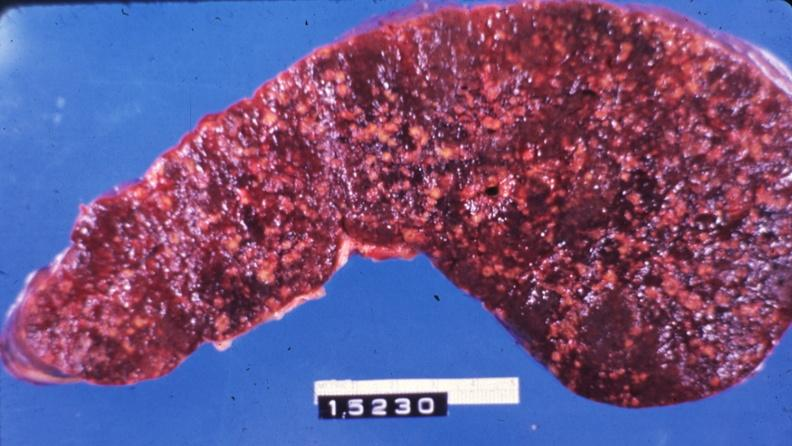what is present?
Answer the question using a single word or phrase. Malignant histiocytosis 